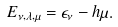<formula> <loc_0><loc_0><loc_500><loc_500>E _ { \nu , \lambda , \mu } = \epsilon _ { \nu } - h \mu .</formula> 